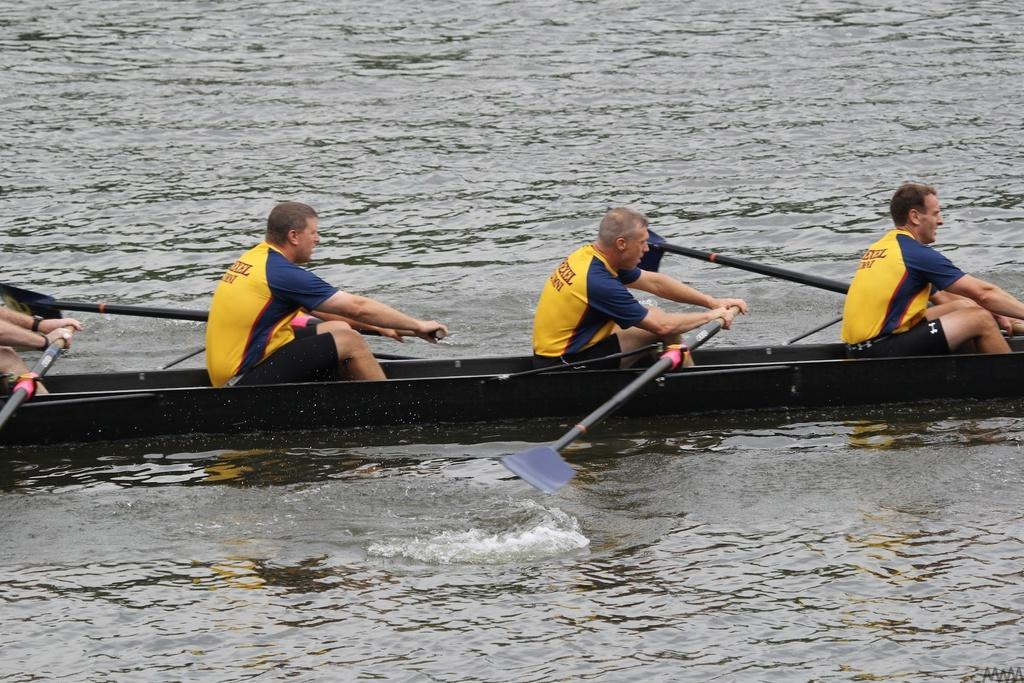What are the people in the image doing? The people in the image are sitting in a boat. Where is the boat located in the image? The boat is in the center of the image. What can be seen at the bottom of the image? There is water visible at the bottom of the image. What type of cushion is being used by the people in the boat? There is no cushion visible in the image; the people are sitting directly on the boat. 